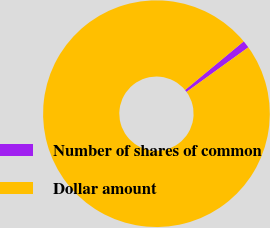<chart> <loc_0><loc_0><loc_500><loc_500><pie_chart><fcel>Number of shares of common<fcel>Dollar amount<nl><fcel>1.06%<fcel>98.94%<nl></chart> 